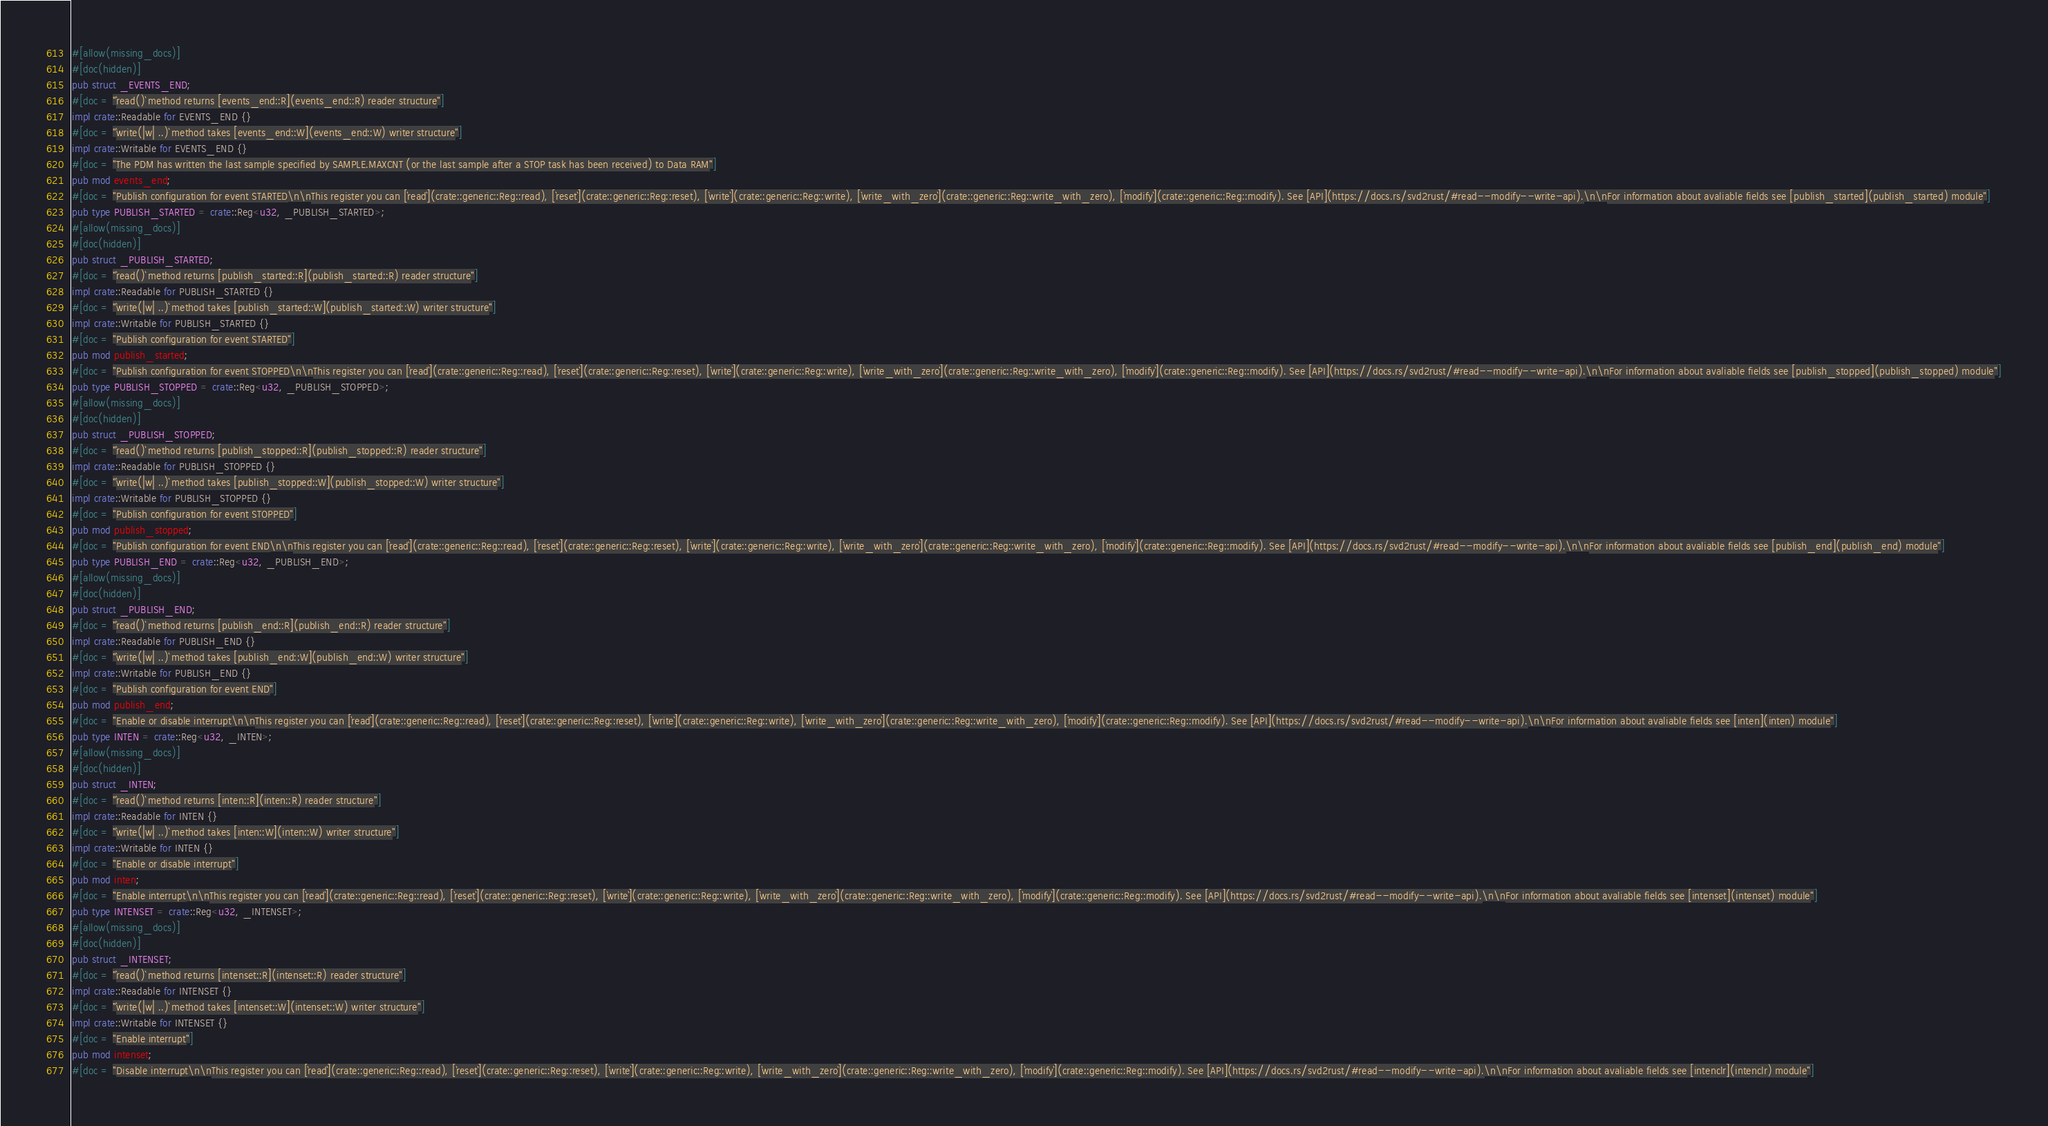<code> <loc_0><loc_0><loc_500><loc_500><_Rust_>#[allow(missing_docs)]
#[doc(hidden)]
pub struct _EVENTS_END;
#[doc = "`read()` method returns [events_end::R](events_end::R) reader structure"]
impl crate::Readable for EVENTS_END {}
#[doc = "`write(|w| ..)` method takes [events_end::W](events_end::W) writer structure"]
impl crate::Writable for EVENTS_END {}
#[doc = "The PDM has written the last sample specified by SAMPLE.MAXCNT (or the last sample after a STOP task has been received) to Data RAM"]
pub mod events_end;
#[doc = "Publish configuration for event STARTED\n\nThis register you can [`read`](crate::generic::Reg::read), [`reset`](crate::generic::Reg::reset), [`write`](crate::generic::Reg::write), [`write_with_zero`](crate::generic::Reg::write_with_zero), [`modify`](crate::generic::Reg::modify). See [API](https://docs.rs/svd2rust/#read--modify--write-api).\n\nFor information about avaliable fields see [publish_started](publish_started) module"]
pub type PUBLISH_STARTED = crate::Reg<u32, _PUBLISH_STARTED>;
#[allow(missing_docs)]
#[doc(hidden)]
pub struct _PUBLISH_STARTED;
#[doc = "`read()` method returns [publish_started::R](publish_started::R) reader structure"]
impl crate::Readable for PUBLISH_STARTED {}
#[doc = "`write(|w| ..)` method takes [publish_started::W](publish_started::W) writer structure"]
impl crate::Writable for PUBLISH_STARTED {}
#[doc = "Publish configuration for event STARTED"]
pub mod publish_started;
#[doc = "Publish configuration for event STOPPED\n\nThis register you can [`read`](crate::generic::Reg::read), [`reset`](crate::generic::Reg::reset), [`write`](crate::generic::Reg::write), [`write_with_zero`](crate::generic::Reg::write_with_zero), [`modify`](crate::generic::Reg::modify). See [API](https://docs.rs/svd2rust/#read--modify--write-api).\n\nFor information about avaliable fields see [publish_stopped](publish_stopped) module"]
pub type PUBLISH_STOPPED = crate::Reg<u32, _PUBLISH_STOPPED>;
#[allow(missing_docs)]
#[doc(hidden)]
pub struct _PUBLISH_STOPPED;
#[doc = "`read()` method returns [publish_stopped::R](publish_stopped::R) reader structure"]
impl crate::Readable for PUBLISH_STOPPED {}
#[doc = "`write(|w| ..)` method takes [publish_stopped::W](publish_stopped::W) writer structure"]
impl crate::Writable for PUBLISH_STOPPED {}
#[doc = "Publish configuration for event STOPPED"]
pub mod publish_stopped;
#[doc = "Publish configuration for event END\n\nThis register you can [`read`](crate::generic::Reg::read), [`reset`](crate::generic::Reg::reset), [`write`](crate::generic::Reg::write), [`write_with_zero`](crate::generic::Reg::write_with_zero), [`modify`](crate::generic::Reg::modify). See [API](https://docs.rs/svd2rust/#read--modify--write-api).\n\nFor information about avaliable fields see [publish_end](publish_end) module"]
pub type PUBLISH_END = crate::Reg<u32, _PUBLISH_END>;
#[allow(missing_docs)]
#[doc(hidden)]
pub struct _PUBLISH_END;
#[doc = "`read()` method returns [publish_end::R](publish_end::R) reader structure"]
impl crate::Readable for PUBLISH_END {}
#[doc = "`write(|w| ..)` method takes [publish_end::W](publish_end::W) writer structure"]
impl crate::Writable for PUBLISH_END {}
#[doc = "Publish configuration for event END"]
pub mod publish_end;
#[doc = "Enable or disable interrupt\n\nThis register you can [`read`](crate::generic::Reg::read), [`reset`](crate::generic::Reg::reset), [`write`](crate::generic::Reg::write), [`write_with_zero`](crate::generic::Reg::write_with_zero), [`modify`](crate::generic::Reg::modify). See [API](https://docs.rs/svd2rust/#read--modify--write-api).\n\nFor information about avaliable fields see [inten](inten) module"]
pub type INTEN = crate::Reg<u32, _INTEN>;
#[allow(missing_docs)]
#[doc(hidden)]
pub struct _INTEN;
#[doc = "`read()` method returns [inten::R](inten::R) reader structure"]
impl crate::Readable for INTEN {}
#[doc = "`write(|w| ..)` method takes [inten::W](inten::W) writer structure"]
impl crate::Writable for INTEN {}
#[doc = "Enable or disable interrupt"]
pub mod inten;
#[doc = "Enable interrupt\n\nThis register you can [`read`](crate::generic::Reg::read), [`reset`](crate::generic::Reg::reset), [`write`](crate::generic::Reg::write), [`write_with_zero`](crate::generic::Reg::write_with_zero), [`modify`](crate::generic::Reg::modify). See [API](https://docs.rs/svd2rust/#read--modify--write-api).\n\nFor information about avaliable fields see [intenset](intenset) module"]
pub type INTENSET = crate::Reg<u32, _INTENSET>;
#[allow(missing_docs)]
#[doc(hidden)]
pub struct _INTENSET;
#[doc = "`read()` method returns [intenset::R](intenset::R) reader structure"]
impl crate::Readable for INTENSET {}
#[doc = "`write(|w| ..)` method takes [intenset::W](intenset::W) writer structure"]
impl crate::Writable for INTENSET {}
#[doc = "Enable interrupt"]
pub mod intenset;
#[doc = "Disable interrupt\n\nThis register you can [`read`](crate::generic::Reg::read), [`reset`](crate::generic::Reg::reset), [`write`](crate::generic::Reg::write), [`write_with_zero`](crate::generic::Reg::write_with_zero), [`modify`](crate::generic::Reg::modify). See [API](https://docs.rs/svd2rust/#read--modify--write-api).\n\nFor information about avaliable fields see [intenclr](intenclr) module"]</code> 